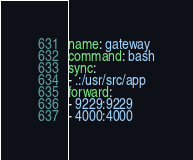<code> <loc_0><loc_0><loc_500><loc_500><_YAML_>name: gateway
command: bash
sync:
- .:/usr/src/app
forward:
- 9229:9229
- 4000:4000
</code> 